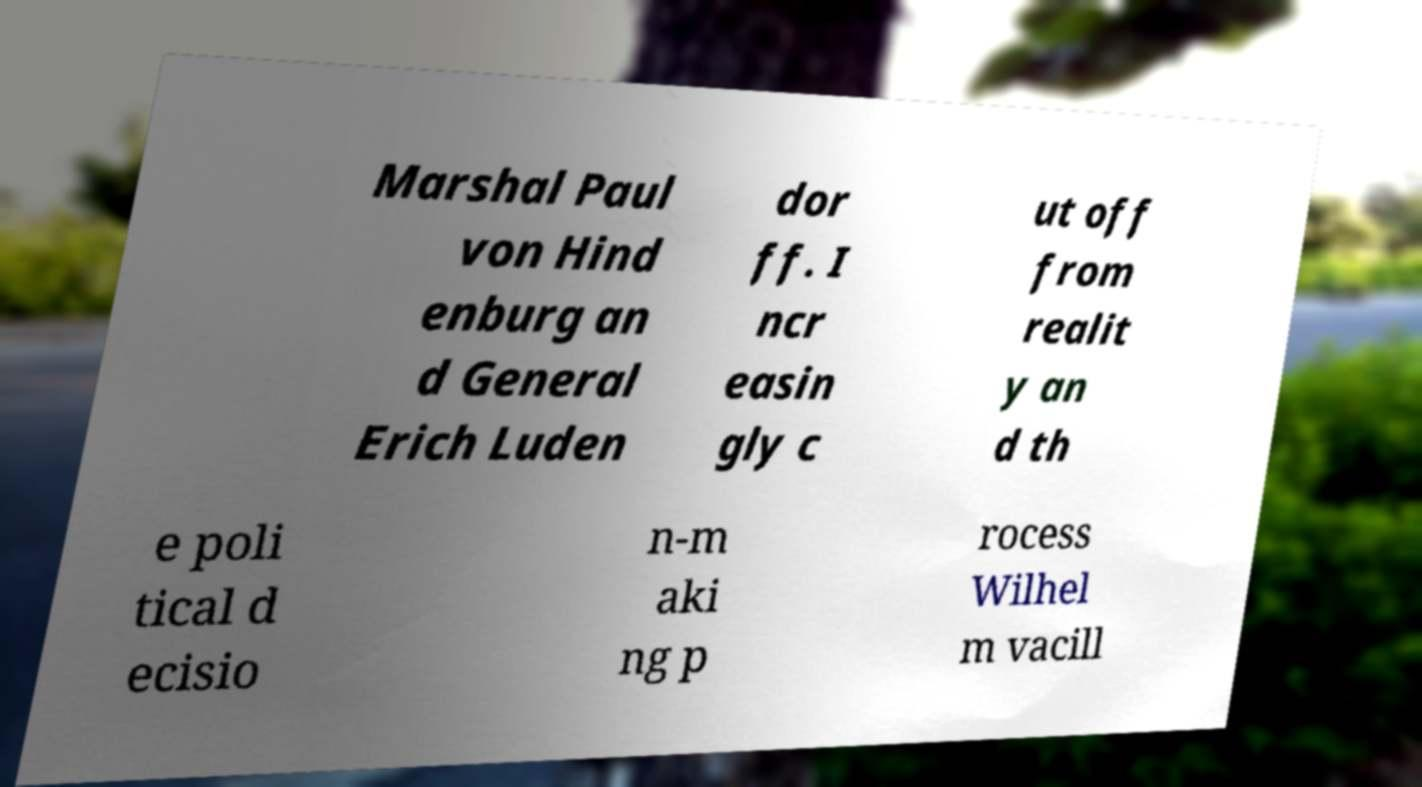Can you read and provide the text displayed in the image?This photo seems to have some interesting text. Can you extract and type it out for me? Marshal Paul von Hind enburg an d General Erich Luden dor ff. I ncr easin gly c ut off from realit y an d th e poli tical d ecisio n-m aki ng p rocess Wilhel m vacill 